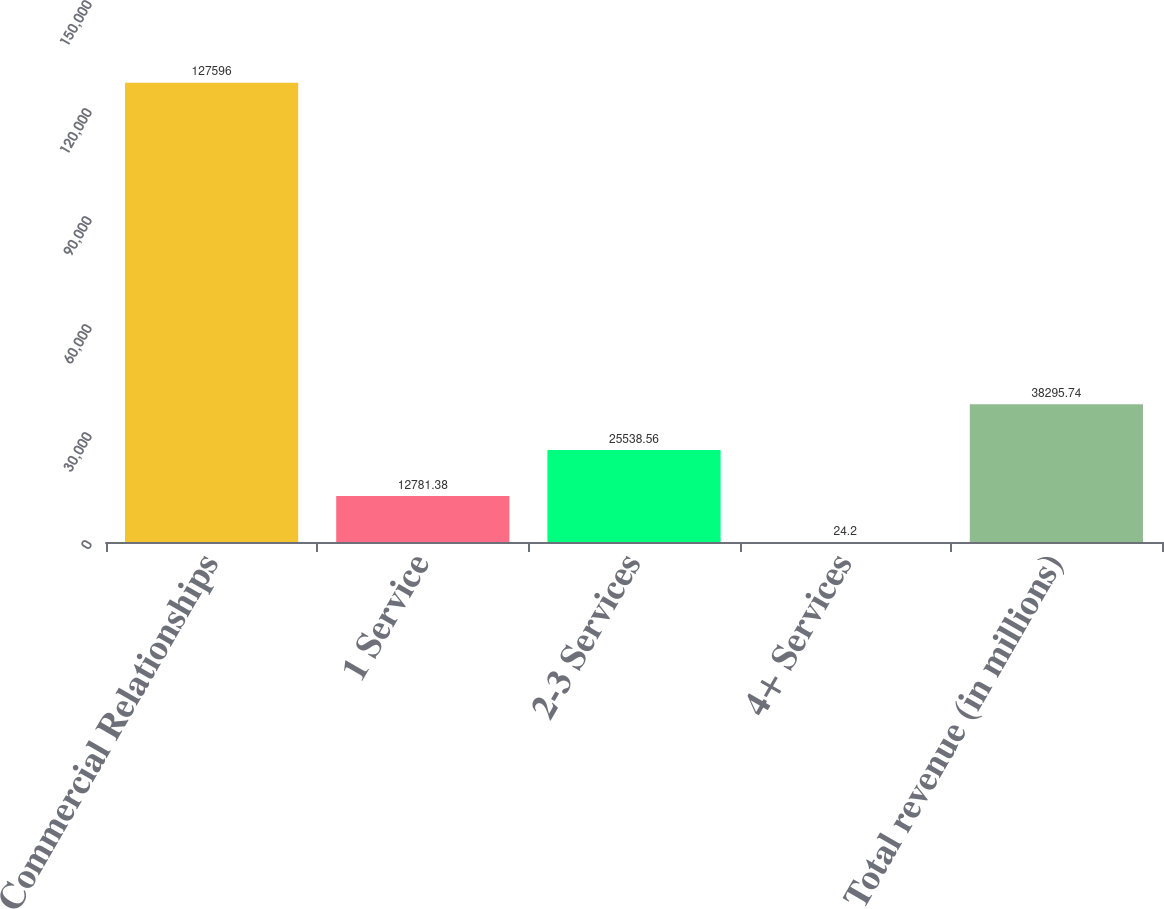<chart> <loc_0><loc_0><loc_500><loc_500><bar_chart><fcel>Commercial Relationships<fcel>1 Service<fcel>2-3 Services<fcel>4+ Services<fcel>Total revenue (in millions)<nl><fcel>127596<fcel>12781.4<fcel>25538.6<fcel>24.2<fcel>38295.7<nl></chart> 